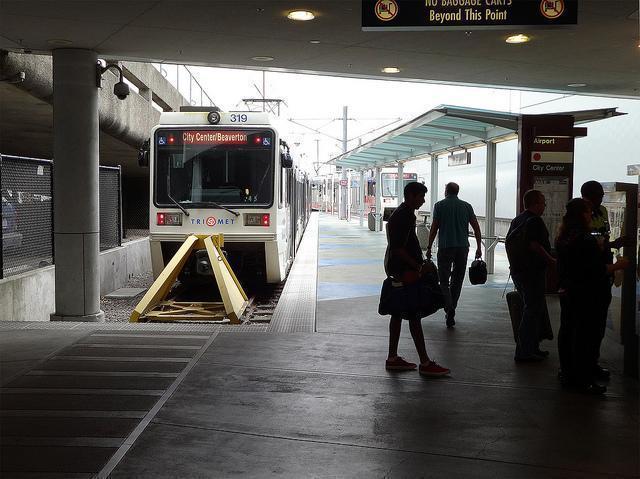The people carrying bags are doing so because of what reason?
Make your selection from the four choices given to correctly answer the question.
Options: Shopping, commuting, weather, air travel. Air travel. 